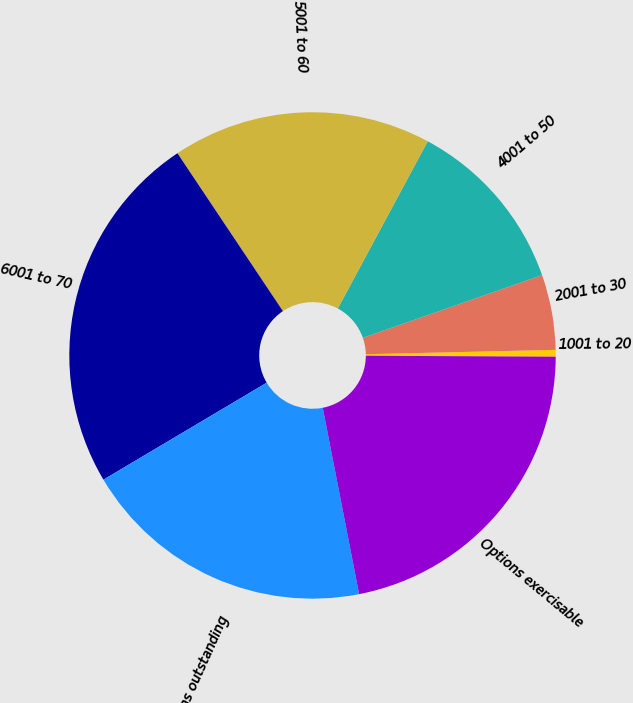Convert chart. <chart><loc_0><loc_0><loc_500><loc_500><pie_chart><fcel>1001 to 20<fcel>2001 to 30<fcel>4001 to 50<fcel>5001 to 60<fcel>6001 to 70<fcel>Options outstanding<fcel>Options exercisable<nl><fcel>0.45%<fcel>4.99%<fcel>11.79%<fcel>17.23%<fcel>24.16%<fcel>19.54%<fcel>21.85%<nl></chart> 